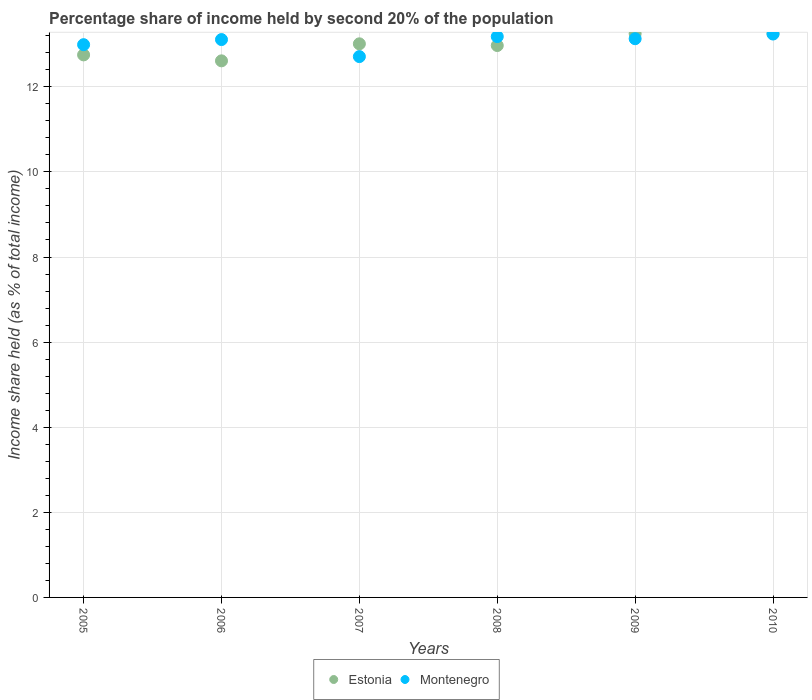Is the number of dotlines equal to the number of legend labels?
Provide a succinct answer. Yes. What is the share of income held by second 20% of the population in Estonia in 2005?
Provide a succinct answer. 12.75. Across all years, what is the maximum share of income held by second 20% of the population in Montenegro?
Your response must be concise. 13.24. Across all years, what is the minimum share of income held by second 20% of the population in Estonia?
Ensure brevity in your answer.  12.61. In which year was the share of income held by second 20% of the population in Montenegro maximum?
Keep it short and to the point. 2010. What is the total share of income held by second 20% of the population in Estonia in the graph?
Provide a succinct answer. 77.84. What is the difference between the share of income held by second 20% of the population in Estonia in 2006 and that in 2008?
Your answer should be very brief. -0.36. What is the difference between the share of income held by second 20% of the population in Estonia in 2005 and the share of income held by second 20% of the population in Montenegro in 2010?
Provide a short and direct response. -0.49. What is the average share of income held by second 20% of the population in Montenegro per year?
Your answer should be compact. 13.06. In the year 2007, what is the difference between the share of income held by second 20% of the population in Estonia and share of income held by second 20% of the population in Montenegro?
Offer a terse response. 0.3. In how many years, is the share of income held by second 20% of the population in Montenegro greater than 6 %?
Keep it short and to the point. 6. What is the ratio of the share of income held by second 20% of the population in Estonia in 2008 to that in 2009?
Provide a succinct answer. 0.98. What is the difference between the highest and the second highest share of income held by second 20% of the population in Montenegro?
Keep it short and to the point. 0.06. What is the difference between the highest and the lowest share of income held by second 20% of the population in Montenegro?
Your response must be concise. 0.53. In how many years, is the share of income held by second 20% of the population in Estonia greater than the average share of income held by second 20% of the population in Estonia taken over all years?
Provide a short and direct response. 3. Does the share of income held by second 20% of the population in Montenegro monotonically increase over the years?
Your answer should be very brief. No. Is the share of income held by second 20% of the population in Montenegro strictly greater than the share of income held by second 20% of the population in Estonia over the years?
Keep it short and to the point. No. How many years are there in the graph?
Offer a very short reply. 6. What is the difference between two consecutive major ticks on the Y-axis?
Provide a short and direct response. 2. Does the graph contain any zero values?
Ensure brevity in your answer.  No. Where does the legend appear in the graph?
Provide a succinct answer. Bottom center. How many legend labels are there?
Your response must be concise. 2. How are the legend labels stacked?
Ensure brevity in your answer.  Horizontal. What is the title of the graph?
Provide a short and direct response. Percentage share of income held by second 20% of the population. Does "Myanmar" appear as one of the legend labels in the graph?
Provide a succinct answer. No. What is the label or title of the X-axis?
Keep it short and to the point. Years. What is the label or title of the Y-axis?
Give a very brief answer. Income share held (as % of total income). What is the Income share held (as % of total income) in Estonia in 2005?
Your answer should be compact. 12.75. What is the Income share held (as % of total income) in Montenegro in 2005?
Ensure brevity in your answer.  12.99. What is the Income share held (as % of total income) of Estonia in 2006?
Offer a very short reply. 12.61. What is the Income share held (as % of total income) in Montenegro in 2006?
Provide a succinct answer. 13.11. What is the Income share held (as % of total income) of Estonia in 2007?
Your answer should be very brief. 13.01. What is the Income share held (as % of total income) in Montenegro in 2007?
Your answer should be compact. 12.71. What is the Income share held (as % of total income) in Estonia in 2008?
Offer a terse response. 12.97. What is the Income share held (as % of total income) in Montenegro in 2008?
Make the answer very short. 13.18. What is the Income share held (as % of total income) in Estonia in 2009?
Offer a very short reply. 13.25. What is the Income share held (as % of total income) of Montenegro in 2009?
Ensure brevity in your answer.  13.13. What is the Income share held (as % of total income) in Estonia in 2010?
Provide a short and direct response. 13.25. What is the Income share held (as % of total income) in Montenegro in 2010?
Make the answer very short. 13.24. Across all years, what is the maximum Income share held (as % of total income) of Estonia?
Provide a succinct answer. 13.25. Across all years, what is the maximum Income share held (as % of total income) of Montenegro?
Your answer should be very brief. 13.24. Across all years, what is the minimum Income share held (as % of total income) in Estonia?
Your answer should be compact. 12.61. Across all years, what is the minimum Income share held (as % of total income) in Montenegro?
Your answer should be very brief. 12.71. What is the total Income share held (as % of total income) in Estonia in the graph?
Provide a succinct answer. 77.84. What is the total Income share held (as % of total income) of Montenegro in the graph?
Give a very brief answer. 78.36. What is the difference between the Income share held (as % of total income) in Estonia in 2005 and that in 2006?
Give a very brief answer. 0.14. What is the difference between the Income share held (as % of total income) of Montenegro in 2005 and that in 2006?
Your answer should be very brief. -0.12. What is the difference between the Income share held (as % of total income) of Estonia in 2005 and that in 2007?
Offer a terse response. -0.26. What is the difference between the Income share held (as % of total income) in Montenegro in 2005 and that in 2007?
Make the answer very short. 0.28. What is the difference between the Income share held (as % of total income) of Estonia in 2005 and that in 2008?
Provide a short and direct response. -0.22. What is the difference between the Income share held (as % of total income) of Montenegro in 2005 and that in 2008?
Offer a terse response. -0.19. What is the difference between the Income share held (as % of total income) in Estonia in 2005 and that in 2009?
Your response must be concise. -0.5. What is the difference between the Income share held (as % of total income) of Montenegro in 2005 and that in 2009?
Your answer should be very brief. -0.14. What is the difference between the Income share held (as % of total income) in Estonia in 2005 and that in 2010?
Offer a terse response. -0.5. What is the difference between the Income share held (as % of total income) in Montenegro in 2005 and that in 2010?
Provide a short and direct response. -0.25. What is the difference between the Income share held (as % of total income) of Estonia in 2006 and that in 2007?
Keep it short and to the point. -0.4. What is the difference between the Income share held (as % of total income) in Estonia in 2006 and that in 2008?
Offer a terse response. -0.36. What is the difference between the Income share held (as % of total income) of Montenegro in 2006 and that in 2008?
Provide a succinct answer. -0.07. What is the difference between the Income share held (as % of total income) of Estonia in 2006 and that in 2009?
Your response must be concise. -0.64. What is the difference between the Income share held (as % of total income) in Montenegro in 2006 and that in 2009?
Ensure brevity in your answer.  -0.02. What is the difference between the Income share held (as % of total income) in Estonia in 2006 and that in 2010?
Offer a very short reply. -0.64. What is the difference between the Income share held (as % of total income) in Montenegro in 2006 and that in 2010?
Provide a succinct answer. -0.13. What is the difference between the Income share held (as % of total income) of Montenegro in 2007 and that in 2008?
Keep it short and to the point. -0.47. What is the difference between the Income share held (as % of total income) of Estonia in 2007 and that in 2009?
Your response must be concise. -0.24. What is the difference between the Income share held (as % of total income) in Montenegro in 2007 and that in 2009?
Your answer should be very brief. -0.42. What is the difference between the Income share held (as % of total income) in Estonia in 2007 and that in 2010?
Your response must be concise. -0.24. What is the difference between the Income share held (as % of total income) in Montenegro in 2007 and that in 2010?
Make the answer very short. -0.53. What is the difference between the Income share held (as % of total income) in Estonia in 2008 and that in 2009?
Offer a terse response. -0.28. What is the difference between the Income share held (as % of total income) of Estonia in 2008 and that in 2010?
Your answer should be compact. -0.28. What is the difference between the Income share held (as % of total income) in Montenegro in 2008 and that in 2010?
Make the answer very short. -0.06. What is the difference between the Income share held (as % of total income) of Montenegro in 2009 and that in 2010?
Give a very brief answer. -0.11. What is the difference between the Income share held (as % of total income) in Estonia in 2005 and the Income share held (as % of total income) in Montenegro in 2006?
Provide a short and direct response. -0.36. What is the difference between the Income share held (as % of total income) in Estonia in 2005 and the Income share held (as % of total income) in Montenegro in 2008?
Provide a short and direct response. -0.43. What is the difference between the Income share held (as % of total income) in Estonia in 2005 and the Income share held (as % of total income) in Montenegro in 2009?
Your answer should be compact. -0.38. What is the difference between the Income share held (as % of total income) of Estonia in 2005 and the Income share held (as % of total income) of Montenegro in 2010?
Ensure brevity in your answer.  -0.49. What is the difference between the Income share held (as % of total income) of Estonia in 2006 and the Income share held (as % of total income) of Montenegro in 2008?
Provide a succinct answer. -0.57. What is the difference between the Income share held (as % of total income) of Estonia in 2006 and the Income share held (as % of total income) of Montenegro in 2009?
Provide a succinct answer. -0.52. What is the difference between the Income share held (as % of total income) of Estonia in 2006 and the Income share held (as % of total income) of Montenegro in 2010?
Provide a short and direct response. -0.63. What is the difference between the Income share held (as % of total income) of Estonia in 2007 and the Income share held (as % of total income) of Montenegro in 2008?
Ensure brevity in your answer.  -0.17. What is the difference between the Income share held (as % of total income) in Estonia in 2007 and the Income share held (as % of total income) in Montenegro in 2009?
Offer a very short reply. -0.12. What is the difference between the Income share held (as % of total income) in Estonia in 2007 and the Income share held (as % of total income) in Montenegro in 2010?
Ensure brevity in your answer.  -0.23. What is the difference between the Income share held (as % of total income) in Estonia in 2008 and the Income share held (as % of total income) in Montenegro in 2009?
Offer a terse response. -0.16. What is the difference between the Income share held (as % of total income) in Estonia in 2008 and the Income share held (as % of total income) in Montenegro in 2010?
Keep it short and to the point. -0.27. What is the difference between the Income share held (as % of total income) of Estonia in 2009 and the Income share held (as % of total income) of Montenegro in 2010?
Keep it short and to the point. 0.01. What is the average Income share held (as % of total income) of Estonia per year?
Provide a succinct answer. 12.97. What is the average Income share held (as % of total income) of Montenegro per year?
Your answer should be very brief. 13.06. In the year 2005, what is the difference between the Income share held (as % of total income) in Estonia and Income share held (as % of total income) in Montenegro?
Your response must be concise. -0.24. In the year 2006, what is the difference between the Income share held (as % of total income) of Estonia and Income share held (as % of total income) of Montenegro?
Your answer should be very brief. -0.5. In the year 2008, what is the difference between the Income share held (as % of total income) in Estonia and Income share held (as % of total income) in Montenegro?
Ensure brevity in your answer.  -0.21. In the year 2009, what is the difference between the Income share held (as % of total income) in Estonia and Income share held (as % of total income) in Montenegro?
Your answer should be compact. 0.12. In the year 2010, what is the difference between the Income share held (as % of total income) of Estonia and Income share held (as % of total income) of Montenegro?
Provide a succinct answer. 0.01. What is the ratio of the Income share held (as % of total income) of Estonia in 2005 to that in 2006?
Your answer should be compact. 1.01. What is the ratio of the Income share held (as % of total income) of Montenegro in 2005 to that in 2006?
Make the answer very short. 0.99. What is the ratio of the Income share held (as % of total income) of Estonia in 2005 to that in 2007?
Offer a very short reply. 0.98. What is the ratio of the Income share held (as % of total income) in Montenegro in 2005 to that in 2007?
Your answer should be very brief. 1.02. What is the ratio of the Income share held (as % of total income) of Montenegro in 2005 to that in 2008?
Keep it short and to the point. 0.99. What is the ratio of the Income share held (as % of total income) in Estonia in 2005 to that in 2009?
Your answer should be very brief. 0.96. What is the ratio of the Income share held (as % of total income) of Montenegro in 2005 to that in 2009?
Ensure brevity in your answer.  0.99. What is the ratio of the Income share held (as % of total income) of Estonia in 2005 to that in 2010?
Keep it short and to the point. 0.96. What is the ratio of the Income share held (as % of total income) of Montenegro in 2005 to that in 2010?
Ensure brevity in your answer.  0.98. What is the ratio of the Income share held (as % of total income) of Estonia in 2006 to that in 2007?
Your answer should be compact. 0.97. What is the ratio of the Income share held (as % of total income) in Montenegro in 2006 to that in 2007?
Offer a very short reply. 1.03. What is the ratio of the Income share held (as % of total income) in Estonia in 2006 to that in 2008?
Ensure brevity in your answer.  0.97. What is the ratio of the Income share held (as % of total income) of Montenegro in 2006 to that in 2008?
Give a very brief answer. 0.99. What is the ratio of the Income share held (as % of total income) in Estonia in 2006 to that in 2009?
Provide a short and direct response. 0.95. What is the ratio of the Income share held (as % of total income) in Montenegro in 2006 to that in 2009?
Make the answer very short. 1. What is the ratio of the Income share held (as % of total income) of Estonia in 2006 to that in 2010?
Give a very brief answer. 0.95. What is the ratio of the Income share held (as % of total income) in Montenegro in 2006 to that in 2010?
Your answer should be compact. 0.99. What is the ratio of the Income share held (as % of total income) in Estonia in 2007 to that in 2008?
Provide a succinct answer. 1. What is the ratio of the Income share held (as % of total income) in Estonia in 2007 to that in 2009?
Your answer should be compact. 0.98. What is the ratio of the Income share held (as % of total income) of Estonia in 2007 to that in 2010?
Give a very brief answer. 0.98. What is the ratio of the Income share held (as % of total income) of Montenegro in 2007 to that in 2010?
Your answer should be compact. 0.96. What is the ratio of the Income share held (as % of total income) of Estonia in 2008 to that in 2009?
Give a very brief answer. 0.98. What is the ratio of the Income share held (as % of total income) in Montenegro in 2008 to that in 2009?
Offer a very short reply. 1. What is the ratio of the Income share held (as % of total income) of Estonia in 2008 to that in 2010?
Give a very brief answer. 0.98. What is the ratio of the Income share held (as % of total income) in Montenegro in 2009 to that in 2010?
Offer a very short reply. 0.99. What is the difference between the highest and the second highest Income share held (as % of total income) in Montenegro?
Your answer should be very brief. 0.06. What is the difference between the highest and the lowest Income share held (as % of total income) in Estonia?
Keep it short and to the point. 0.64. What is the difference between the highest and the lowest Income share held (as % of total income) of Montenegro?
Give a very brief answer. 0.53. 